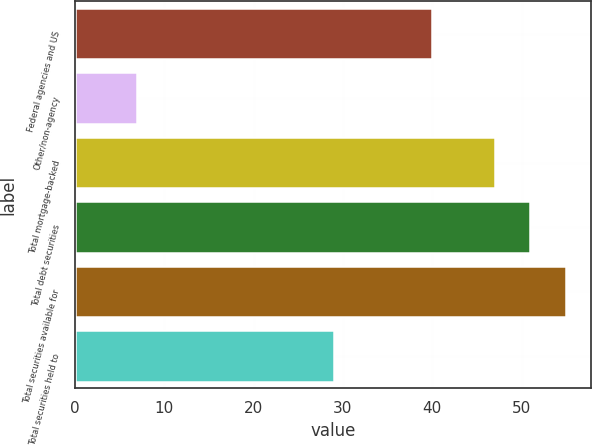Convert chart to OTSL. <chart><loc_0><loc_0><loc_500><loc_500><bar_chart><fcel>Federal agencies and US<fcel>Other/non-agency<fcel>Total mortgage-backed<fcel>Total debt securities<fcel>Total securities available for<fcel>Total securities held to<nl><fcel>40<fcel>7<fcel>47<fcel>51<fcel>55<fcel>29<nl></chart> 